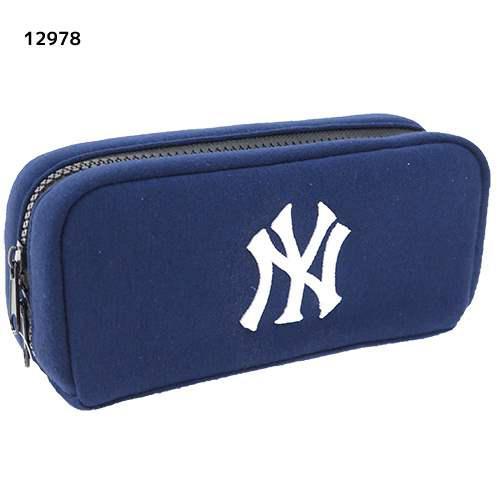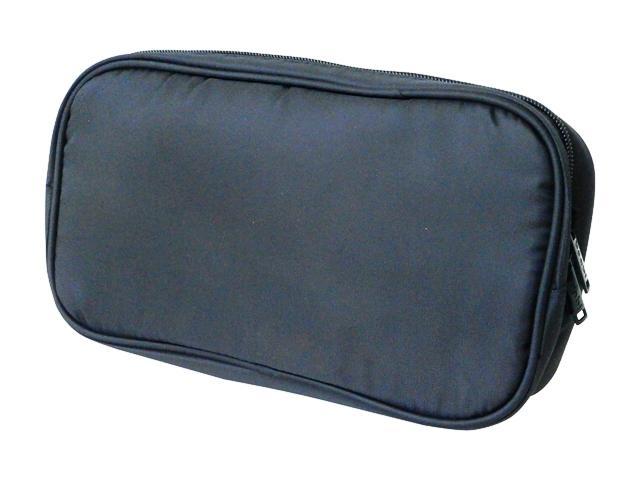The first image is the image on the left, the second image is the image on the right. Assess this claim about the two images: "One bag is unzipped.". Correct or not? Answer yes or no. No. The first image is the image on the left, the second image is the image on the right. For the images displayed, is the sentence "A pouch is unzipped  and open in one of the images." factually correct? Answer yes or no. No. 